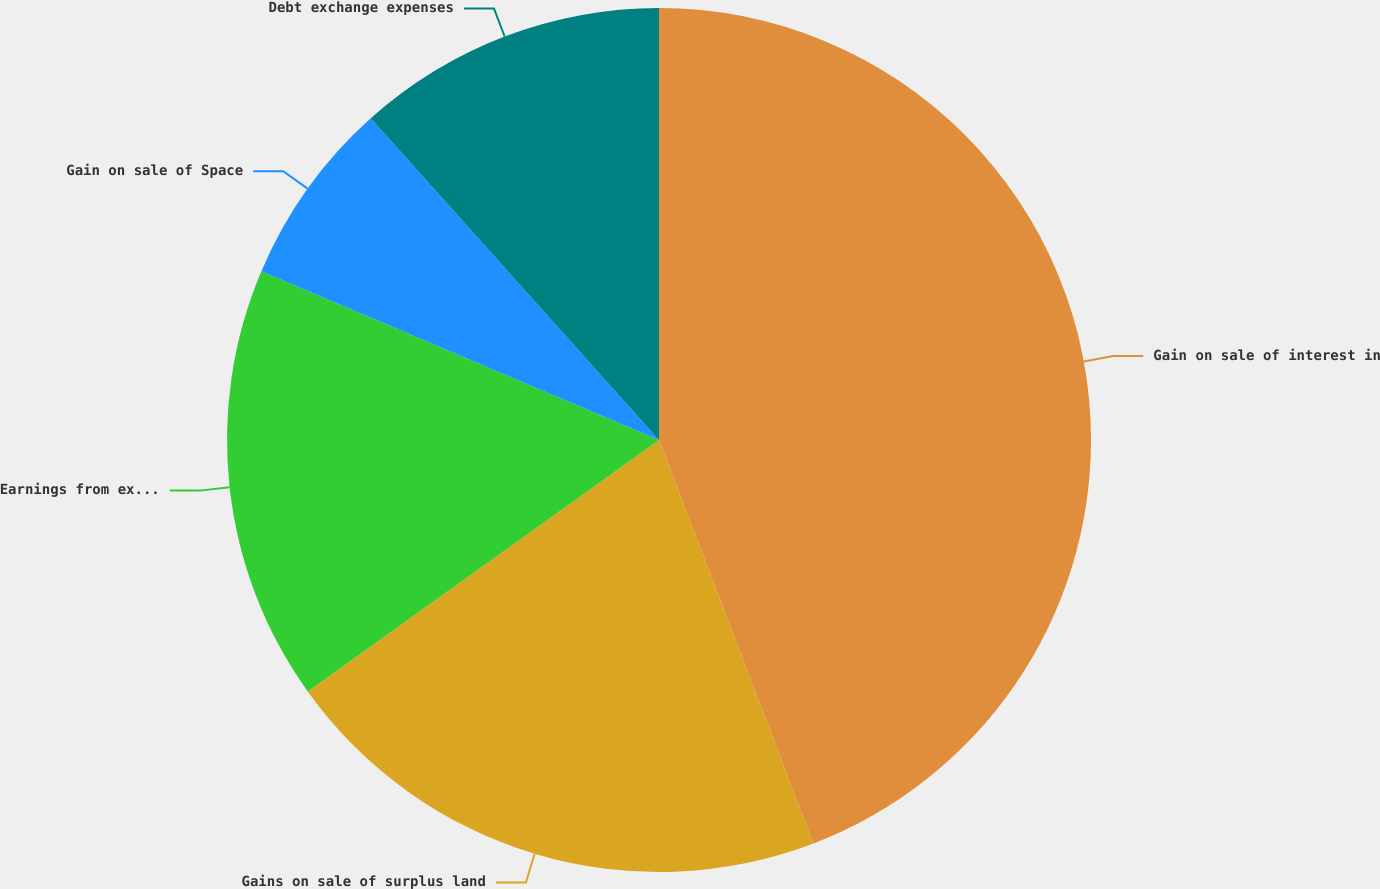<chart> <loc_0><loc_0><loc_500><loc_500><pie_chart><fcel>Gain on sale of interest in<fcel>Gains on sale of surplus land<fcel>Earnings from expiration of<fcel>Gain on sale of Space<fcel>Debt exchange expenses<nl><fcel>44.19%<fcel>20.93%<fcel>16.28%<fcel>6.98%<fcel>11.63%<nl></chart> 